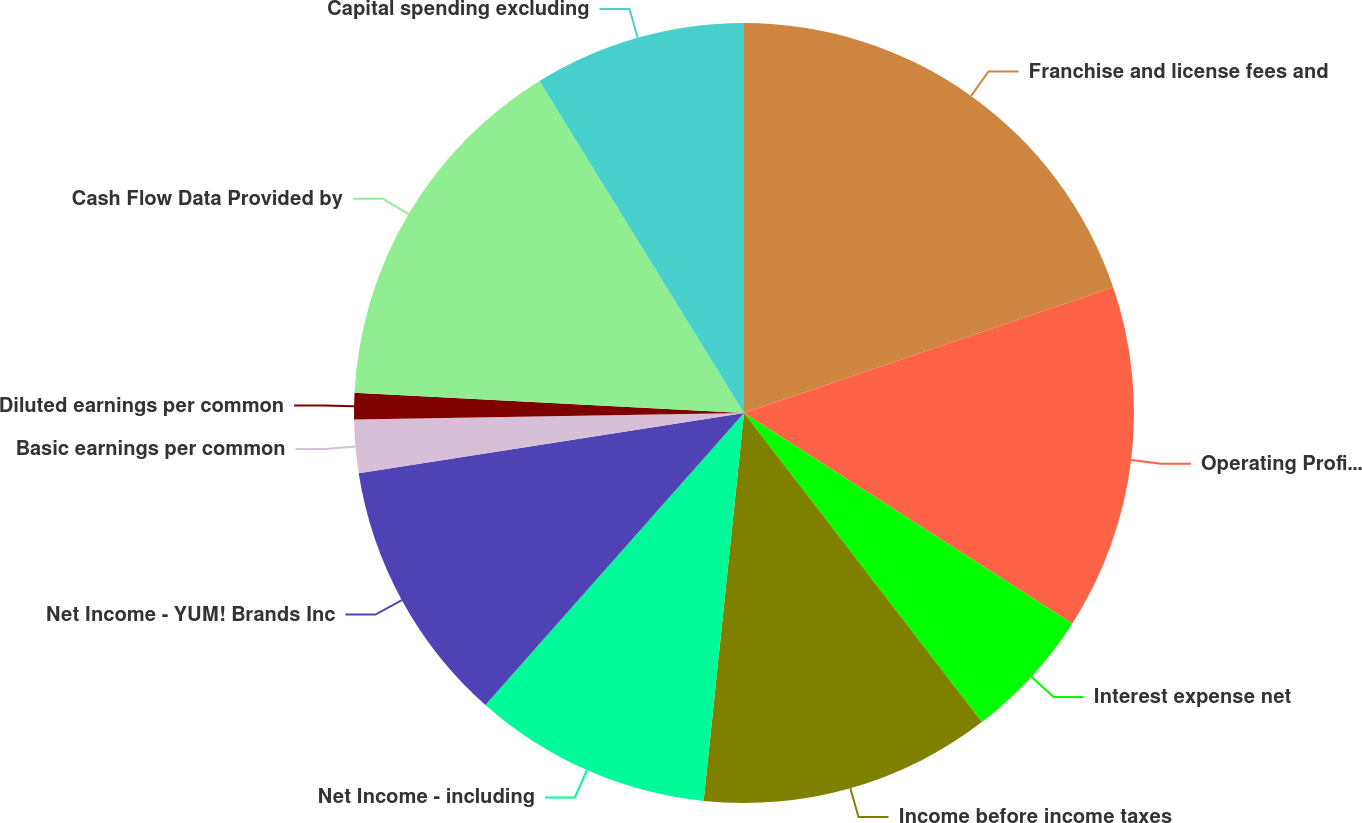Convert chart to OTSL. <chart><loc_0><loc_0><loc_500><loc_500><pie_chart><fcel>Franchise and license fees and<fcel>Operating Profit^(c)<fcel>Interest expense net<fcel>Income before income taxes<fcel>Net Income - including<fcel>Net Income - YUM! Brands Inc<fcel>Basic earnings per common<fcel>Diluted earnings per common<fcel>Cash Flow Data Provided by<fcel>Capital spending excluding<nl><fcel>19.78%<fcel>14.29%<fcel>5.49%<fcel>12.09%<fcel>9.89%<fcel>10.99%<fcel>2.2%<fcel>1.1%<fcel>15.38%<fcel>8.79%<nl></chart> 